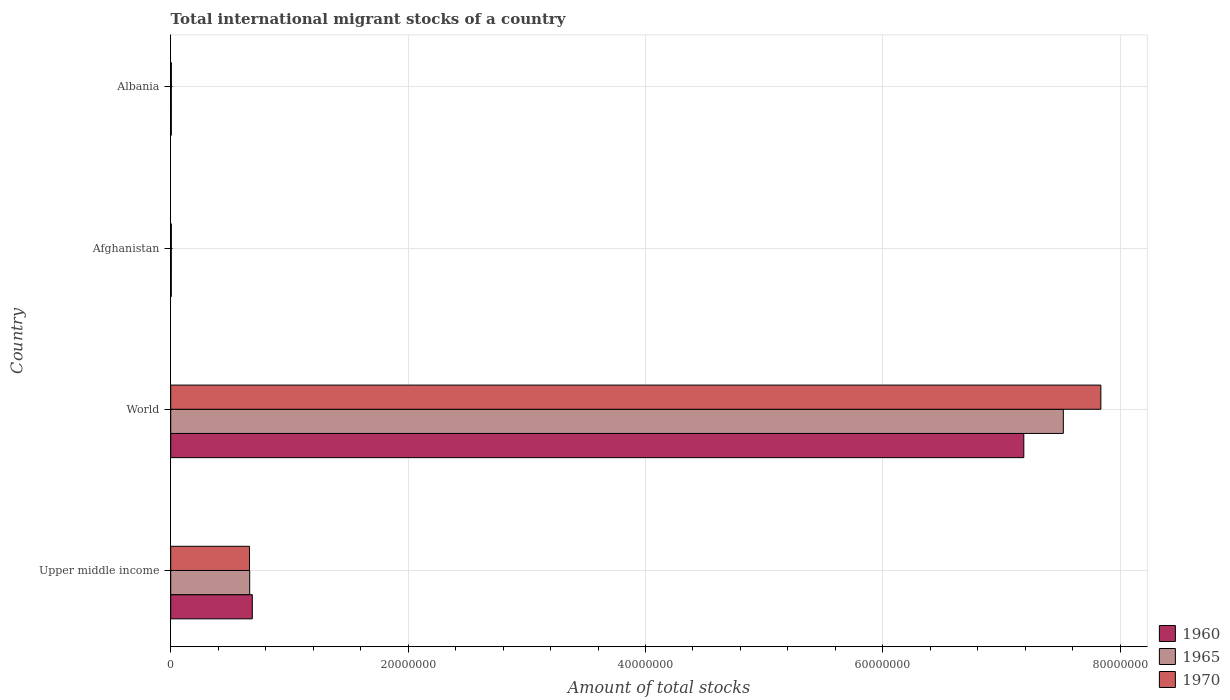How many different coloured bars are there?
Keep it short and to the point. 3. How many groups of bars are there?
Ensure brevity in your answer.  4. Are the number of bars per tick equal to the number of legend labels?
Give a very brief answer. Yes. How many bars are there on the 2nd tick from the top?
Give a very brief answer. 3. How many bars are there on the 1st tick from the bottom?
Offer a terse response. 3. What is the label of the 4th group of bars from the top?
Keep it short and to the point. Upper middle income. In how many cases, is the number of bars for a given country not equal to the number of legend labels?
Your answer should be very brief. 0. What is the amount of total stocks in in 1960 in Upper middle income?
Make the answer very short. 6.87e+06. Across all countries, what is the maximum amount of total stocks in in 1965?
Provide a short and direct response. 7.52e+07. Across all countries, what is the minimum amount of total stocks in in 1960?
Your response must be concise. 4.65e+04. In which country was the amount of total stocks in in 1970 minimum?
Keep it short and to the point. Afghanistan. What is the total amount of total stocks in in 1965 in the graph?
Your response must be concise. 8.20e+07. What is the difference between the amount of total stocks in in 1970 in Upper middle income and that in World?
Your response must be concise. -7.17e+07. What is the difference between the amount of total stocks in in 1970 in Upper middle income and the amount of total stocks in in 1965 in Afghanistan?
Provide a short and direct response. 6.59e+06. What is the average amount of total stocks in in 1960 per country?
Provide a succinct answer. 1.97e+07. What is the difference between the amount of total stocks in in 1965 and amount of total stocks in in 1960 in World?
Your response must be concise. 3.33e+06. In how many countries, is the amount of total stocks in in 1960 greater than 48000000 ?
Your answer should be compact. 1. What is the ratio of the amount of total stocks in in 1960 in Albania to that in Upper middle income?
Offer a terse response. 0.01. Is the amount of total stocks in in 1965 in Albania less than that in World?
Keep it short and to the point. Yes. What is the difference between the highest and the second highest amount of total stocks in in 1960?
Keep it short and to the point. 6.50e+07. What is the difference between the highest and the lowest amount of total stocks in in 1965?
Provide a short and direct response. 7.52e+07. What does the 3rd bar from the top in Afghanistan represents?
Your answer should be very brief. 1960. What does the 2nd bar from the bottom in Albania represents?
Make the answer very short. 1965. Are all the bars in the graph horizontal?
Provide a succinct answer. Yes. How many countries are there in the graph?
Offer a very short reply. 4. Are the values on the major ticks of X-axis written in scientific E-notation?
Keep it short and to the point. No. Where does the legend appear in the graph?
Ensure brevity in your answer.  Bottom right. What is the title of the graph?
Your response must be concise. Total international migrant stocks of a country. What is the label or title of the X-axis?
Your answer should be compact. Amount of total stocks. What is the label or title of the Y-axis?
Your response must be concise. Country. What is the Amount of total stocks of 1960 in Upper middle income?
Make the answer very short. 6.87e+06. What is the Amount of total stocks of 1965 in Upper middle income?
Your answer should be compact. 6.65e+06. What is the Amount of total stocks of 1970 in Upper middle income?
Your answer should be compact. 6.64e+06. What is the Amount of total stocks in 1960 in World?
Offer a very short reply. 7.19e+07. What is the Amount of total stocks of 1965 in World?
Ensure brevity in your answer.  7.52e+07. What is the Amount of total stocks in 1970 in World?
Keep it short and to the point. 7.84e+07. What is the Amount of total stocks of 1960 in Afghanistan?
Provide a succinct answer. 4.65e+04. What is the Amount of total stocks of 1965 in Afghanistan?
Offer a terse response. 4.95e+04. What is the Amount of total stocks of 1970 in Afghanistan?
Your answer should be very brief. 5.31e+04. What is the Amount of total stocks in 1960 in Albania?
Keep it short and to the point. 4.89e+04. What is the Amount of total stocks of 1965 in Albania?
Your answer should be very brief. 5.14e+04. What is the Amount of total stocks in 1970 in Albania?
Your answer should be very brief. 5.40e+04. Across all countries, what is the maximum Amount of total stocks in 1960?
Offer a very short reply. 7.19e+07. Across all countries, what is the maximum Amount of total stocks in 1965?
Provide a short and direct response. 7.52e+07. Across all countries, what is the maximum Amount of total stocks in 1970?
Your answer should be very brief. 7.84e+07. Across all countries, what is the minimum Amount of total stocks in 1960?
Offer a terse response. 4.65e+04. Across all countries, what is the minimum Amount of total stocks of 1965?
Keep it short and to the point. 4.95e+04. Across all countries, what is the minimum Amount of total stocks of 1970?
Provide a short and direct response. 5.31e+04. What is the total Amount of total stocks of 1960 in the graph?
Provide a succinct answer. 7.88e+07. What is the total Amount of total stocks in 1965 in the graph?
Offer a very short reply. 8.20e+07. What is the total Amount of total stocks in 1970 in the graph?
Make the answer very short. 8.51e+07. What is the difference between the Amount of total stocks in 1960 in Upper middle income and that in World?
Provide a short and direct response. -6.50e+07. What is the difference between the Amount of total stocks in 1965 in Upper middle income and that in World?
Make the answer very short. -6.86e+07. What is the difference between the Amount of total stocks of 1970 in Upper middle income and that in World?
Provide a succinct answer. -7.17e+07. What is the difference between the Amount of total stocks of 1960 in Upper middle income and that in Afghanistan?
Your response must be concise. 6.83e+06. What is the difference between the Amount of total stocks of 1965 in Upper middle income and that in Afghanistan?
Keep it short and to the point. 6.60e+06. What is the difference between the Amount of total stocks of 1970 in Upper middle income and that in Afghanistan?
Your response must be concise. 6.58e+06. What is the difference between the Amount of total stocks in 1960 in Upper middle income and that in Albania?
Offer a very short reply. 6.82e+06. What is the difference between the Amount of total stocks of 1965 in Upper middle income and that in Albania?
Your answer should be very brief. 6.60e+06. What is the difference between the Amount of total stocks of 1970 in Upper middle income and that in Albania?
Provide a succinct answer. 6.58e+06. What is the difference between the Amount of total stocks in 1960 in World and that in Afghanistan?
Provide a short and direct response. 7.18e+07. What is the difference between the Amount of total stocks in 1965 in World and that in Afghanistan?
Your response must be concise. 7.52e+07. What is the difference between the Amount of total stocks of 1970 in World and that in Afghanistan?
Ensure brevity in your answer.  7.83e+07. What is the difference between the Amount of total stocks of 1960 in World and that in Albania?
Ensure brevity in your answer.  7.18e+07. What is the difference between the Amount of total stocks of 1965 in World and that in Albania?
Provide a succinct answer. 7.52e+07. What is the difference between the Amount of total stocks of 1970 in World and that in Albania?
Offer a very short reply. 7.83e+07. What is the difference between the Amount of total stocks of 1960 in Afghanistan and that in Albania?
Provide a short and direct response. -2433. What is the difference between the Amount of total stocks of 1965 in Afghanistan and that in Albania?
Your answer should be very brief. -1874. What is the difference between the Amount of total stocks in 1970 in Afghanistan and that in Albania?
Keep it short and to the point. -994. What is the difference between the Amount of total stocks of 1960 in Upper middle income and the Amount of total stocks of 1965 in World?
Provide a short and direct response. -6.83e+07. What is the difference between the Amount of total stocks in 1960 in Upper middle income and the Amount of total stocks in 1970 in World?
Your response must be concise. -7.15e+07. What is the difference between the Amount of total stocks of 1965 in Upper middle income and the Amount of total stocks of 1970 in World?
Make the answer very short. -7.17e+07. What is the difference between the Amount of total stocks in 1960 in Upper middle income and the Amount of total stocks in 1965 in Afghanistan?
Your response must be concise. 6.82e+06. What is the difference between the Amount of total stocks in 1960 in Upper middle income and the Amount of total stocks in 1970 in Afghanistan?
Provide a short and direct response. 6.82e+06. What is the difference between the Amount of total stocks of 1965 in Upper middle income and the Amount of total stocks of 1970 in Afghanistan?
Provide a short and direct response. 6.60e+06. What is the difference between the Amount of total stocks in 1960 in Upper middle income and the Amount of total stocks in 1965 in Albania?
Provide a succinct answer. 6.82e+06. What is the difference between the Amount of total stocks of 1960 in Upper middle income and the Amount of total stocks of 1970 in Albania?
Your answer should be very brief. 6.82e+06. What is the difference between the Amount of total stocks of 1965 in Upper middle income and the Amount of total stocks of 1970 in Albania?
Your answer should be compact. 6.60e+06. What is the difference between the Amount of total stocks in 1960 in World and the Amount of total stocks in 1965 in Afghanistan?
Your response must be concise. 7.18e+07. What is the difference between the Amount of total stocks of 1960 in World and the Amount of total stocks of 1970 in Afghanistan?
Keep it short and to the point. 7.18e+07. What is the difference between the Amount of total stocks of 1965 in World and the Amount of total stocks of 1970 in Afghanistan?
Your response must be concise. 7.52e+07. What is the difference between the Amount of total stocks of 1960 in World and the Amount of total stocks of 1965 in Albania?
Ensure brevity in your answer.  7.18e+07. What is the difference between the Amount of total stocks of 1960 in World and the Amount of total stocks of 1970 in Albania?
Your answer should be very brief. 7.18e+07. What is the difference between the Amount of total stocks of 1965 in World and the Amount of total stocks of 1970 in Albania?
Keep it short and to the point. 7.52e+07. What is the difference between the Amount of total stocks in 1960 in Afghanistan and the Amount of total stocks in 1965 in Albania?
Your answer should be very brief. -4941. What is the difference between the Amount of total stocks of 1960 in Afghanistan and the Amount of total stocks of 1970 in Albania?
Offer a very short reply. -7577. What is the difference between the Amount of total stocks of 1965 in Afghanistan and the Amount of total stocks of 1970 in Albania?
Offer a terse response. -4510. What is the average Amount of total stocks of 1960 per country?
Offer a terse response. 1.97e+07. What is the average Amount of total stocks in 1965 per country?
Keep it short and to the point. 2.05e+07. What is the average Amount of total stocks of 1970 per country?
Provide a short and direct response. 2.13e+07. What is the difference between the Amount of total stocks in 1960 and Amount of total stocks in 1965 in Upper middle income?
Your answer should be compact. 2.19e+05. What is the difference between the Amount of total stocks in 1960 and Amount of total stocks in 1970 in Upper middle income?
Keep it short and to the point. 2.36e+05. What is the difference between the Amount of total stocks of 1965 and Amount of total stocks of 1970 in Upper middle income?
Provide a succinct answer. 1.70e+04. What is the difference between the Amount of total stocks of 1960 and Amount of total stocks of 1965 in World?
Offer a terse response. -3.33e+06. What is the difference between the Amount of total stocks in 1960 and Amount of total stocks in 1970 in World?
Give a very brief answer. -6.49e+06. What is the difference between the Amount of total stocks in 1965 and Amount of total stocks in 1970 in World?
Your answer should be very brief. -3.16e+06. What is the difference between the Amount of total stocks in 1960 and Amount of total stocks in 1965 in Afghanistan?
Your answer should be very brief. -3067. What is the difference between the Amount of total stocks in 1960 and Amount of total stocks in 1970 in Afghanistan?
Offer a terse response. -6583. What is the difference between the Amount of total stocks of 1965 and Amount of total stocks of 1970 in Afghanistan?
Give a very brief answer. -3516. What is the difference between the Amount of total stocks in 1960 and Amount of total stocks in 1965 in Albania?
Give a very brief answer. -2508. What is the difference between the Amount of total stocks in 1960 and Amount of total stocks in 1970 in Albania?
Provide a short and direct response. -5144. What is the difference between the Amount of total stocks of 1965 and Amount of total stocks of 1970 in Albania?
Your answer should be very brief. -2636. What is the ratio of the Amount of total stocks in 1960 in Upper middle income to that in World?
Keep it short and to the point. 0.1. What is the ratio of the Amount of total stocks of 1965 in Upper middle income to that in World?
Your response must be concise. 0.09. What is the ratio of the Amount of total stocks in 1970 in Upper middle income to that in World?
Your answer should be compact. 0.08. What is the ratio of the Amount of total stocks of 1960 in Upper middle income to that in Afghanistan?
Give a very brief answer. 147.91. What is the ratio of the Amount of total stocks in 1965 in Upper middle income to that in Afghanistan?
Offer a terse response. 134.33. What is the ratio of the Amount of total stocks of 1970 in Upper middle income to that in Afghanistan?
Ensure brevity in your answer.  125.1. What is the ratio of the Amount of total stocks in 1960 in Upper middle income to that in Albania?
Your answer should be very brief. 140.56. What is the ratio of the Amount of total stocks of 1965 in Upper middle income to that in Albania?
Your answer should be compact. 129.43. What is the ratio of the Amount of total stocks of 1970 in Upper middle income to that in Albania?
Give a very brief answer. 122.8. What is the ratio of the Amount of total stocks of 1960 in World to that in Afghanistan?
Ensure brevity in your answer.  1546.81. What is the ratio of the Amount of total stocks of 1965 in World to that in Afghanistan?
Your answer should be very brief. 1518.24. What is the ratio of the Amount of total stocks of 1970 in World to that in Afghanistan?
Give a very brief answer. 1477.22. What is the ratio of the Amount of total stocks in 1960 in World to that in Albania?
Provide a short and direct response. 1469.85. What is the ratio of the Amount of total stocks in 1965 in World to that in Albania?
Your answer should be very brief. 1462.9. What is the ratio of the Amount of total stocks of 1970 in World to that in Albania?
Provide a succinct answer. 1450.05. What is the ratio of the Amount of total stocks of 1960 in Afghanistan to that in Albania?
Keep it short and to the point. 0.95. What is the ratio of the Amount of total stocks in 1965 in Afghanistan to that in Albania?
Ensure brevity in your answer.  0.96. What is the ratio of the Amount of total stocks in 1970 in Afghanistan to that in Albania?
Provide a short and direct response. 0.98. What is the difference between the highest and the second highest Amount of total stocks in 1960?
Give a very brief answer. 6.50e+07. What is the difference between the highest and the second highest Amount of total stocks in 1965?
Offer a terse response. 6.86e+07. What is the difference between the highest and the second highest Amount of total stocks of 1970?
Keep it short and to the point. 7.17e+07. What is the difference between the highest and the lowest Amount of total stocks of 1960?
Offer a very short reply. 7.18e+07. What is the difference between the highest and the lowest Amount of total stocks in 1965?
Your answer should be compact. 7.52e+07. What is the difference between the highest and the lowest Amount of total stocks of 1970?
Your response must be concise. 7.83e+07. 